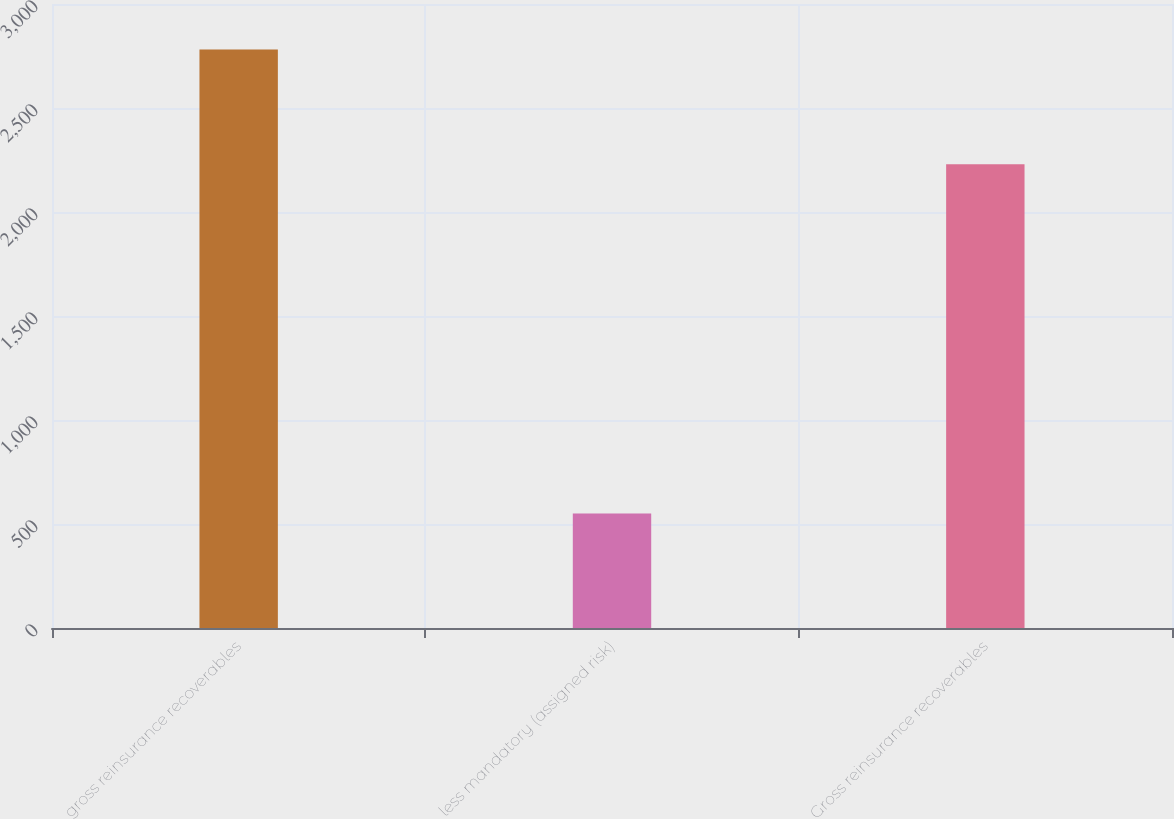Convert chart to OTSL. <chart><loc_0><loc_0><loc_500><loc_500><bar_chart><fcel>gross reinsurance recoverables<fcel>less mandatory (assigned risk)<fcel>Gross reinsurance recoverables<nl><fcel>2781<fcel>551<fcel>2230<nl></chart> 